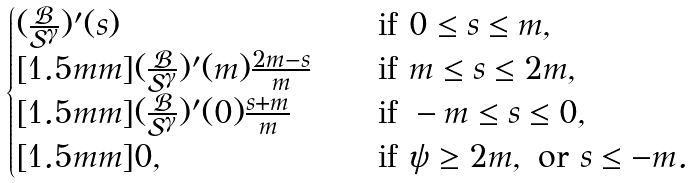Convert formula to latex. <formula><loc_0><loc_0><loc_500><loc_500>\begin{cases} ( \frac { \mathcal { B } } { \mathcal { S } ^ { \gamma } } ) ^ { \prime } ( s ) \quad & \text {if} \ 0 \leq s \leq m , \\ [ 1 . 5 m m ] ( \frac { \mathcal { B } } { \mathcal { S } ^ { \gamma } } ) ^ { \prime } ( m ) \frac { 2 m - s } { m } \quad & \text {if} \ m \leq s \leq 2 m , \\ [ 1 . 5 m m ] ( \frac { \mathcal { B } } { \mathcal { S } ^ { \gamma } } ) ^ { \prime } ( 0 ) \frac { s + m } { m } \quad & \text {if} \ - m \leq s \leq 0 , \\ [ 1 . 5 m m ] 0 , \quad & \text {if} \ \psi \geq 2 m , \ \text {or} \ s \leq - m . \end{cases}</formula> 